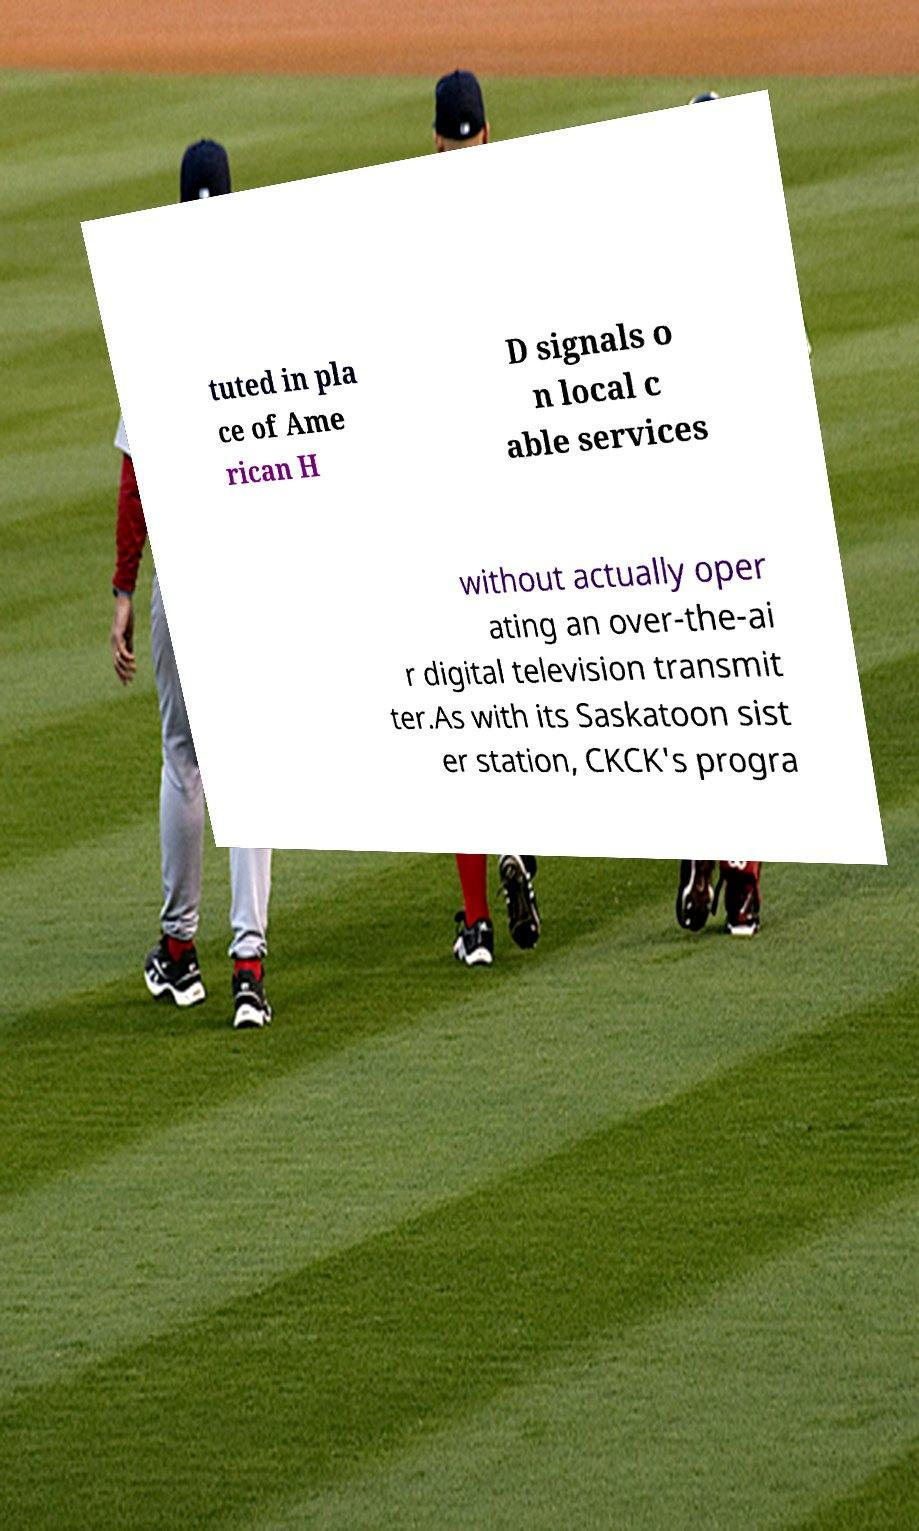I need the written content from this picture converted into text. Can you do that? tuted in pla ce of Ame rican H D signals o n local c able services without actually oper ating an over-the-ai r digital television transmit ter.As with its Saskatoon sist er station, CKCK's progra 